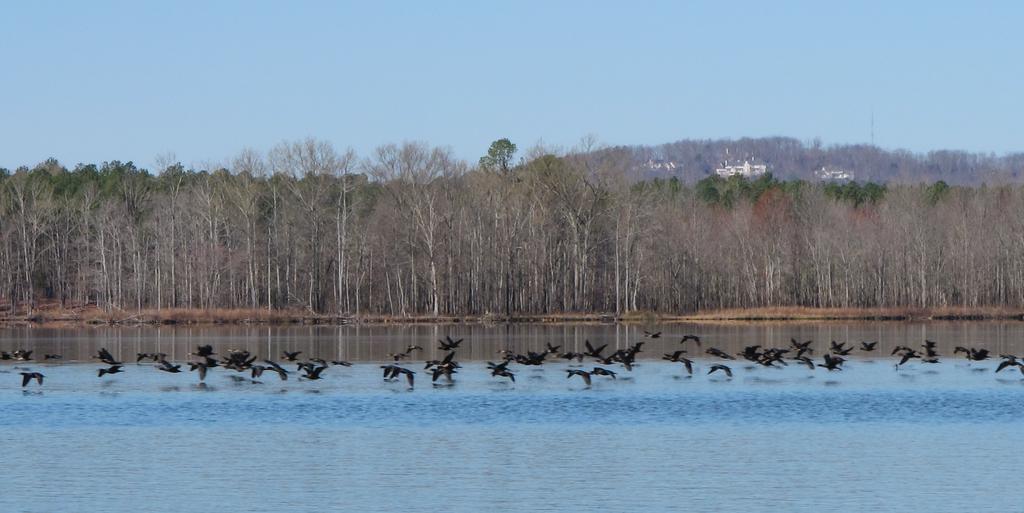In one or two sentences, can you explain what this image depicts? In this image there is water at the bottom. Above the water there are so many black color birds. In the background there are tall trees. At the top there is the sky. 